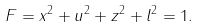Convert formula to latex. <formula><loc_0><loc_0><loc_500><loc_500>F = x ^ { 2 } + u ^ { 2 } + z ^ { 2 } + l ^ { 2 } = 1 .</formula> 